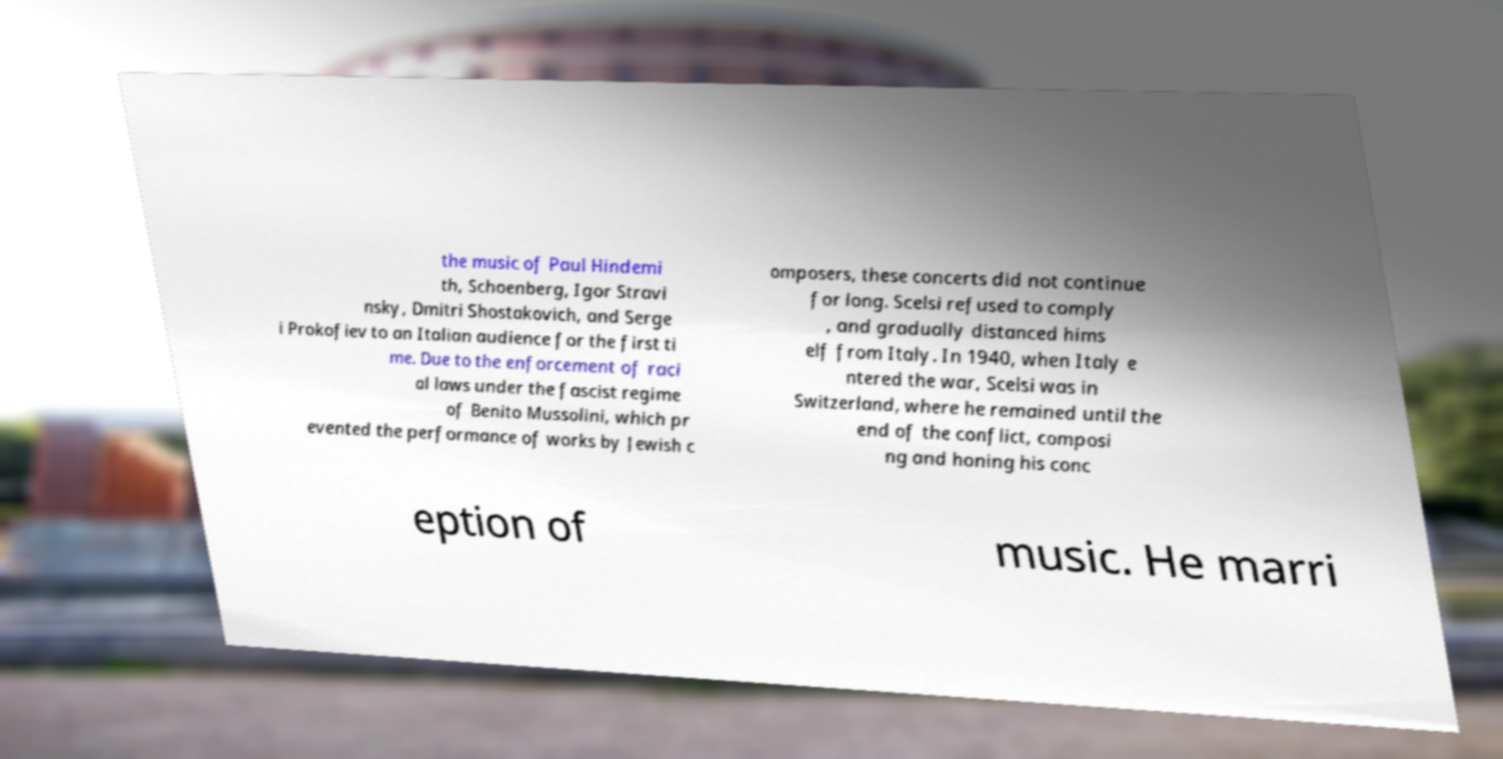Please identify and transcribe the text found in this image. the music of Paul Hindemi th, Schoenberg, Igor Stravi nsky, Dmitri Shostakovich, and Serge i Prokofiev to an Italian audience for the first ti me. Due to the enforcement of raci al laws under the fascist regime of Benito Mussolini, which pr evented the performance of works by Jewish c omposers, these concerts did not continue for long. Scelsi refused to comply , and gradually distanced hims elf from Italy. In 1940, when Italy e ntered the war, Scelsi was in Switzerland, where he remained until the end of the conflict, composi ng and honing his conc eption of music. He marri 